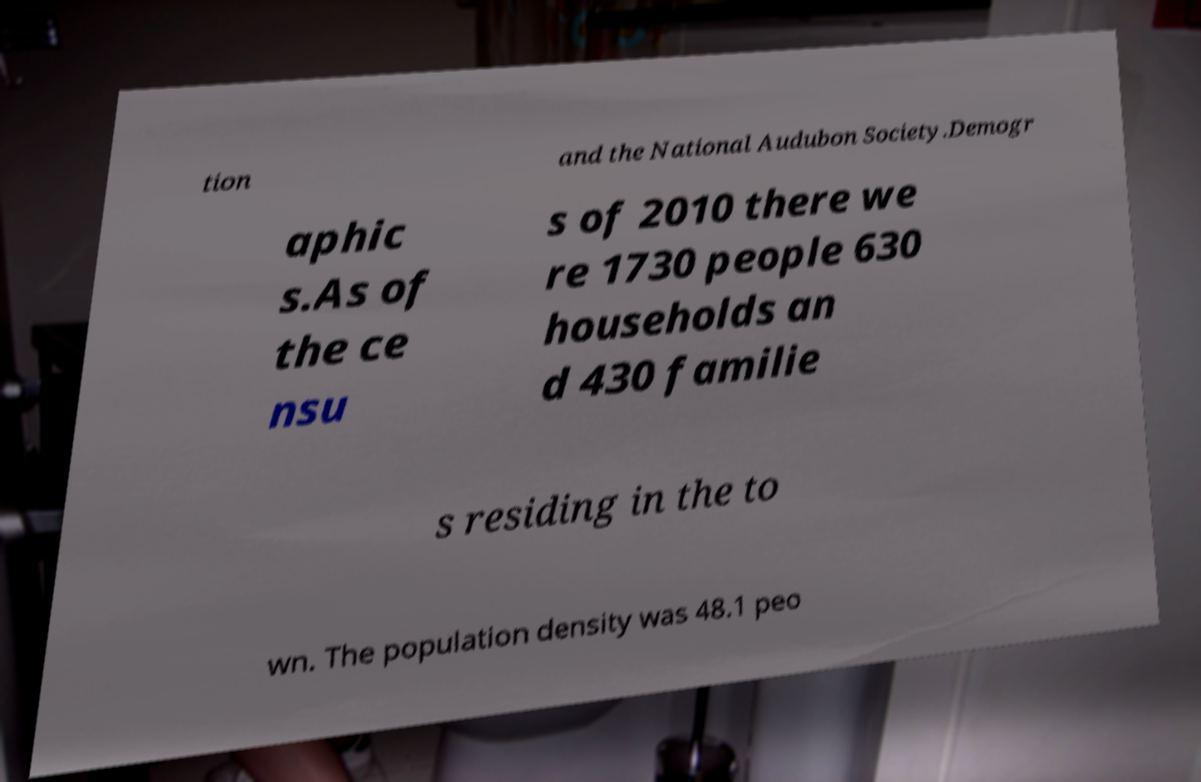Please identify and transcribe the text found in this image. tion and the National Audubon Society.Demogr aphic s.As of the ce nsu s of 2010 there we re 1730 people 630 households an d 430 familie s residing in the to wn. The population density was 48.1 peo 